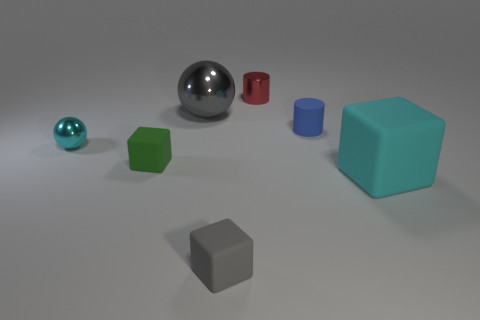Are there any spheres in front of the small matte thing that is behind the sphere in front of the gray shiny sphere?
Offer a very short reply. Yes. What number of other things are the same color as the large rubber thing?
Your answer should be compact. 1. Is the size of the block that is to the right of the red cylinder the same as the gray thing that is behind the big cyan matte cube?
Your answer should be very brief. Yes. Is the number of tiny red metallic things that are to the right of the cyan cube the same as the number of shiny balls behind the tiny matte cylinder?
Your response must be concise. No. There is a gray rubber object; is its size the same as the cyan thing that is in front of the tiny green cube?
Your response must be concise. No. What is the material of the gray thing behind the tiny cyan metal ball behind the gray matte cube?
Your response must be concise. Metal. Are there the same number of small blue objects that are behind the big metallic object and small green cubes?
Ensure brevity in your answer.  No. There is a rubber block that is both to the right of the large ball and left of the large cube; what is its size?
Make the answer very short. Small. What is the color of the small block that is behind the cyan thing to the right of the large gray shiny object?
Give a very brief answer. Green. How many green things are small matte things or small cubes?
Your answer should be very brief. 1. 